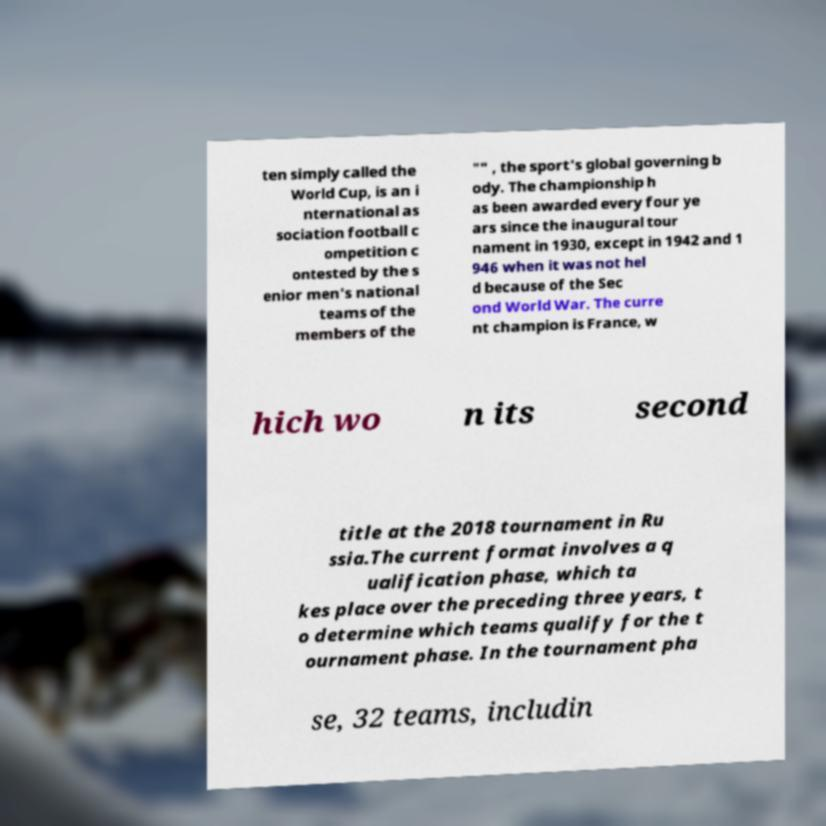Please identify and transcribe the text found in this image. ten simply called the World Cup, is an i nternational as sociation football c ompetition c ontested by the s enior men's national teams of the members of the "" , the sport's global governing b ody. The championship h as been awarded every four ye ars since the inaugural tour nament in 1930, except in 1942 and 1 946 when it was not hel d because of the Sec ond World War. The curre nt champion is France, w hich wo n its second title at the 2018 tournament in Ru ssia.The current format involves a q ualification phase, which ta kes place over the preceding three years, t o determine which teams qualify for the t ournament phase. In the tournament pha se, 32 teams, includin 